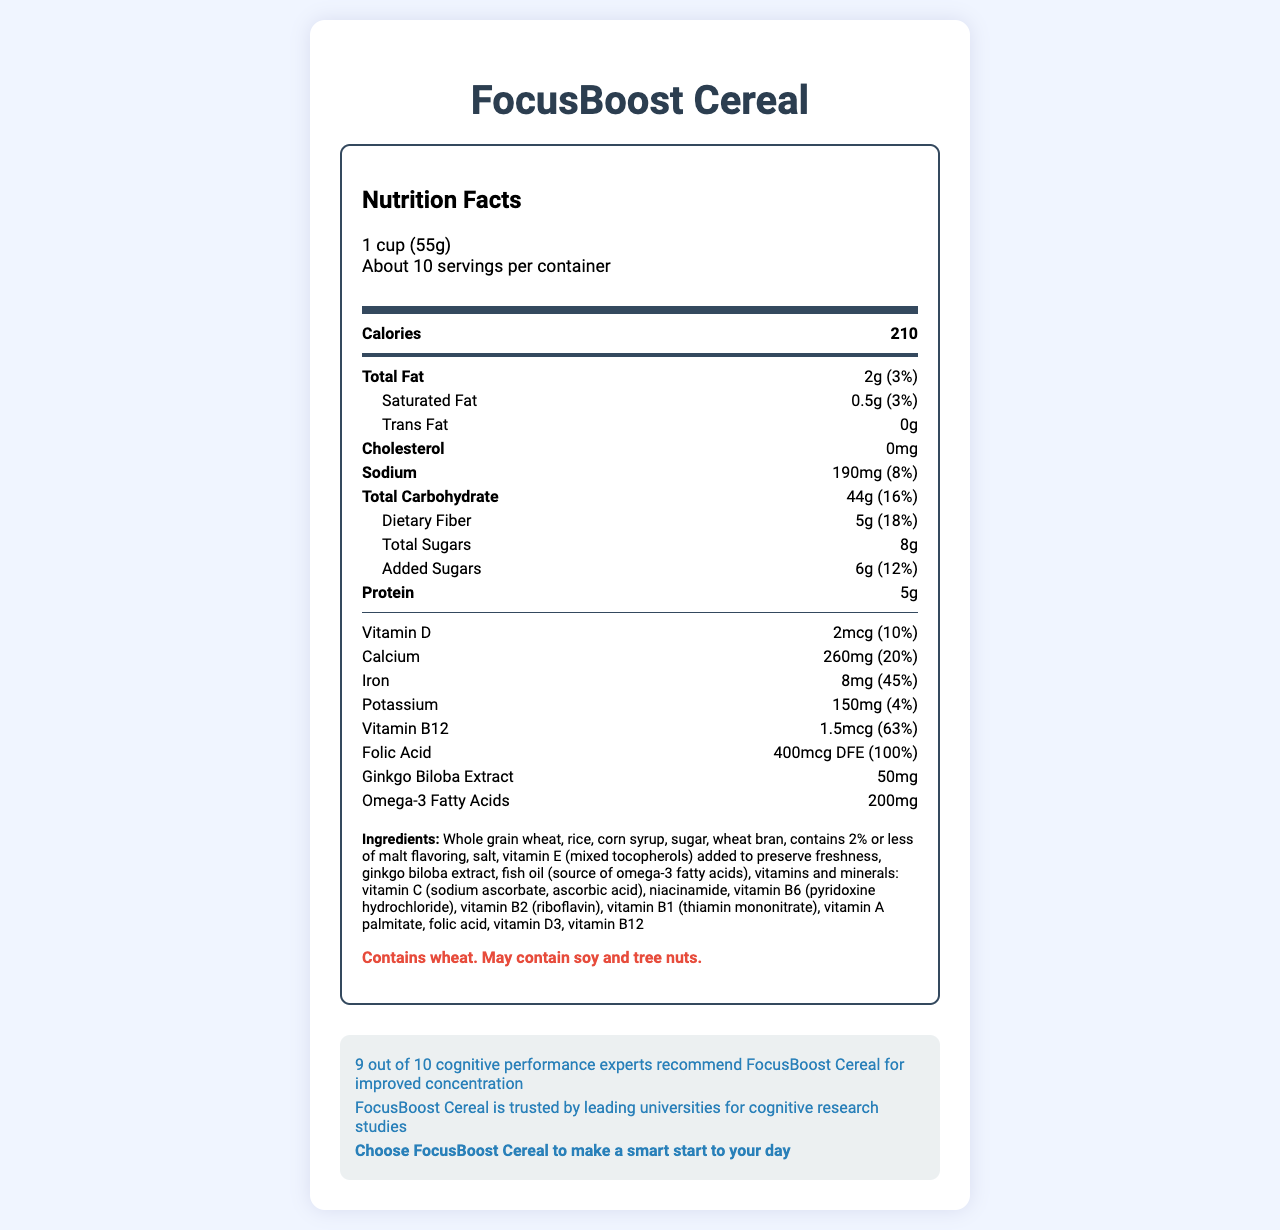what is the serving size? The serving size is explicitly mentioned under the "Nutrition Facts" section as "1 cup (55g)".
Answer: 1 cup (55g) how many calories are there per serving? The calorie content per serving is presented prominently in the "Nutrition Facts" section as "Calories 210".
Answer: 210 what is the daily value percentage of dietary fiber? The "Nutrition Facts" section lists the dietary fiber content as "5g (18%)".
Answer: 18% how much added sugars are there in a serving? The "Nutrition Facts" section mentions the added sugars amount as "Added Sugars: 6g (12%)".
Answer: 6g what are the allergens associated with this cereal? The allergens are detailed under the "Allergen Info" section as "Contains wheat. May contain soy and tree nuts".
Answer: Contains wheat. May contain soy and tree nuts. which vitamin has the highest daily value percentage? A. Vitamin D B. Calcium C. Iron D. Vitamin B12 E. Folic Acid The daily value percentages are listed next to each vitamin and folic acid has the highest at 100%.
Answer: E. Folic Acid what is the sodium content per serving? A. 110mg B. 160mg C. 190mg D. 220mg The sodium content is shown in the "Nutrition Facts" section as "Sodium: 190mg (8%)".
Answer: C. 190mg does this cereal contain trans fat? The "Nutrition Facts" section explicitly states "Trans Fat: 0g".
Answer: No summarize the main purpose of the FocusBoost Cereal. The summary captures the primary aim of the product, as outlined by the claims in the social influence and reputation statements.
Answer: FocusBoost Cereal is a breakfast cereal designed to improve focus and concentration by providing key vitamins, minerals, and ingredients like ginkgo biloba extract and omega-3 fatty acids. It claims to be recommended by cognitive performance experts and trusted by leading universities for cognitive research. how much protein does one serving of the cereal provide? Under the "Nutrition Facts" section, the protein content per serving is listed as "Protein: 5g".
Answer: 5g what are the benefits of the key ingredients like ginkgo biloba extract and omega-3 fatty acids? The document lists these ingredients but does not provide specific benefits they provide, so it cannot be determined purely from the visual information.
Answer: Not enough information how many servings are there per container? The "servings per container" information is given as "About 10".
Answer: About 10 what is the total carbohydrate content and its daily value percentage per serving? The "Nutrition Facts" lists total carbohydrates as "Total Carbohydrate: 44g (16%)".
Answer: 44g (16%) what does the social influence claim state about FocusBoost Cereal? The "social influence claim" states this explicitly in the social proof section.
Answer: 9 out of 10 cognitive performance experts recommend FocusBoost Cereal for improved concentration how many milligrams of calcium are contained per serving? The calcium content is shown in the "Nutrition Facts" section as "Calcium: 260mg (20%)".
Answer: 260mg is FocusBoost Cereal recommended for cognitive research by any reputable institutions? The reputation statement in the social proof section mentions, "FocusBoost Cereal is trusted by leading universities for cognitive research studies".
Answer: Yes 